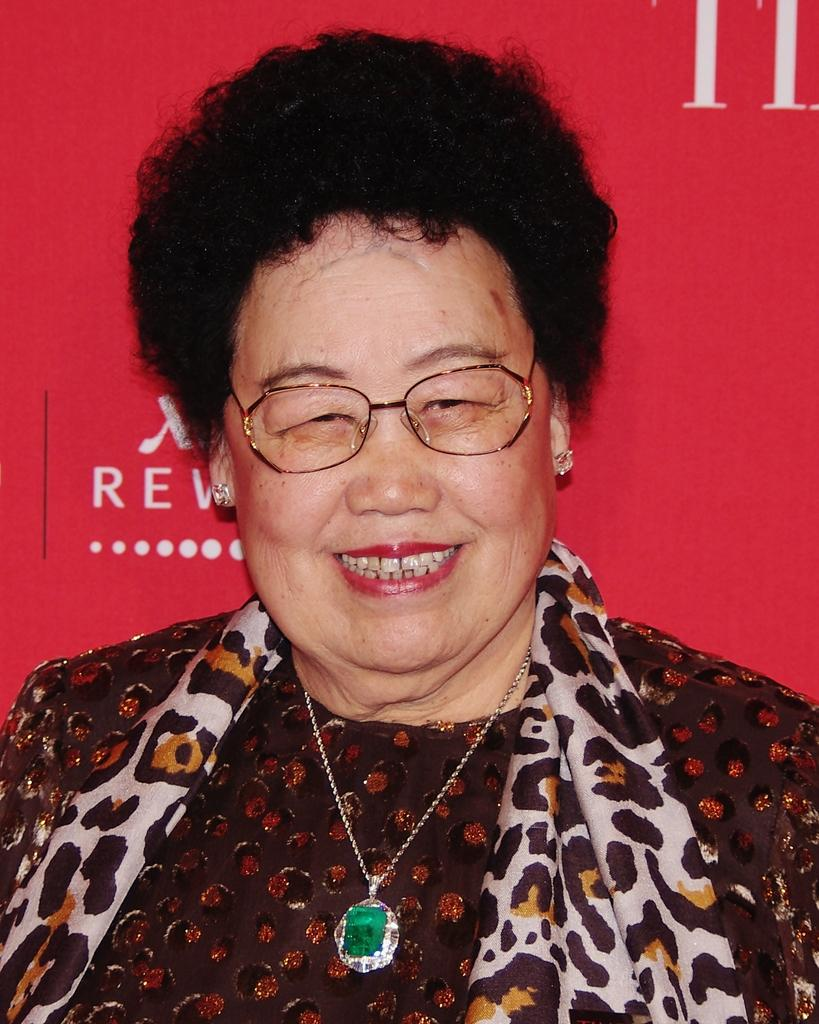Who is the main subject in the image? There is a person in the center of the image. What is the person wearing around their neck? The person is wearing a stole. What is the person wearing on their chest? The person is wearing a locket. What is the person wearing on their face? The person is wearing spectacles. What is the person's facial expression? The person is smiling. What color is the object in the background? There is a red color object in the background. What is written or depicted on the red object in the background? There is text on the red color object in the background. What type of lettuce is being rubbed on the person's face in the image? There is no lettuce or rubbing action present in the image. 